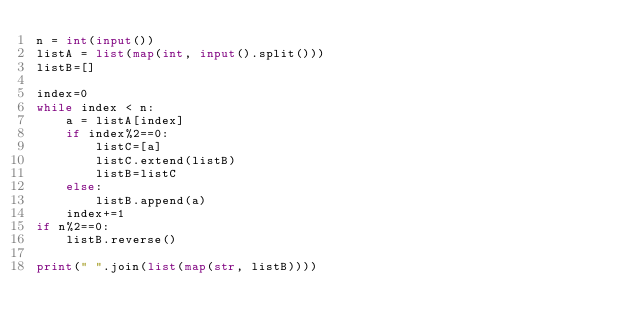Convert code to text. <code><loc_0><loc_0><loc_500><loc_500><_Python_>n = int(input())
listA = list(map(int, input().split()))
listB=[]

index=0
while index < n:
    a = listA[index]
    if index%2==0:
        listC=[a]
        listC.extend(listB)
        listB=listC
    else:
        listB.append(a)
    index+=1
if n%2==0:
    listB.reverse()

print(" ".join(list(map(str, listB))))</code> 